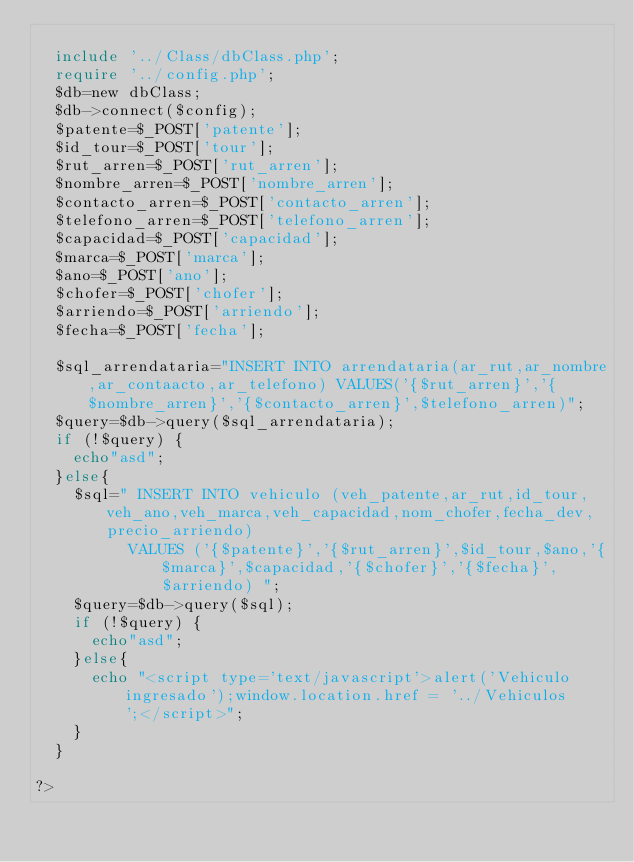<code> <loc_0><loc_0><loc_500><loc_500><_PHP_>
  include '../Class/dbClass.php';
  require '../config.php';
  $db=new dbClass;
  $db->connect($config);
  $patente=$_POST['patente'];
  $id_tour=$_POST['tour'];
  $rut_arren=$_POST['rut_arren'];
  $nombre_arren=$_POST['nombre_arren'];
  $contacto_arren=$_POST['contacto_arren'];
  $telefono_arren=$_POST['telefono_arren'];
  $capacidad=$_POST['capacidad'];
  $marca=$_POST['marca'];
  $ano=$_POST['ano'];
  $chofer=$_POST['chofer'];
  $arriendo=$_POST['arriendo'];
  $fecha=$_POST['fecha'];

  $sql_arrendataria="INSERT INTO arrendataria(ar_rut,ar_nombre,ar_contaacto,ar_telefono) VALUES('{$rut_arren}','{$nombre_arren}','{$contacto_arren}',$telefono_arren)";
  $query=$db->query($sql_arrendataria);
  if (!$query) {
    echo"asd";
  }else{
    $sql=" INSERT INTO vehiculo (veh_patente,ar_rut,id_tour,veh_ano,veh_marca,veh_capacidad,nom_chofer,fecha_dev,precio_arriendo)
          VALUES ('{$patente}','{$rut_arren}',$id_tour,$ano,'{$marca}',$capacidad,'{$chofer}','{$fecha}',$arriendo) ";
    $query=$db->query($sql);
    if (!$query) {
      echo"asd";
    }else{
      echo "<script type='text/javascript'>alert('Vehiculo ingresado');window.location.href = '../Vehiculos ';</script>";
    }
  }

?>
</code> 